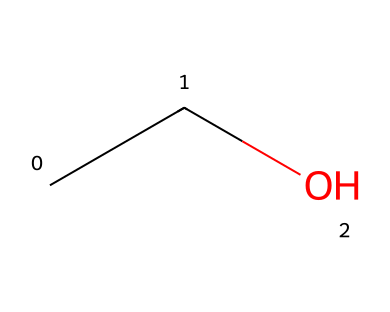What is the molecular formula of this compound? In the SMILES representation "CCO", the two 'C' represent two carbon atoms and the 'O' represents one oxygen atom, leading to the molecular formula C2H6O.
Answer: C2H6O How many hydrogen atoms are present in ethanol? The compound 'CCO' indicates that there are two carbon atoms and an oxygen atom, which contributes to five hydrogen atoms; the full count is H5 (as calculated by the general formula CnH2n+2 for alkanes).
Answer: 6 What type of functional group is found in this molecule? The 'O' in the SMILES indicates the presence of a hydroxyl group (–OH), which is indicative of an alcohol functional group.
Answer: hydroxyl Is ethanol a polar solvent? Ethanol has a hydroxyl group which enhances its polarity due to the electronegativity difference between oxygen and hydrogen, thus making it a polar solvent.
Answer: yes How many carbon-carbon bonds exist in ethanol? The 'CC' in the SMILES indicates a single bond between the two carbon atoms in ethanol; thus, there is one carbon-carbon bond in this molecule.
Answer: 1 Does ethanol mix well with water? Ethanol's polar nature and the ability to form hydrogen bonds with water molecules suggest that it is miscible with water.
Answer: yes What state of matter is ethanol at room temperature? Ethanol has a low boiling point of about 78 degrees Celsius; at room temperature (about 20 degrees Celsius), it exists as a liquid.
Answer: liquid 